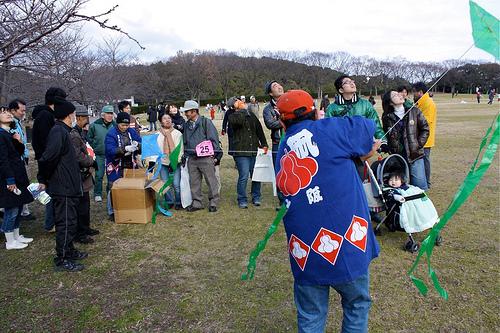Is it summer in this photo?
Be succinct. No. What race are these people?
Give a very brief answer. Asian. What are they looking in the sky for?
Write a very short answer. Kites. 